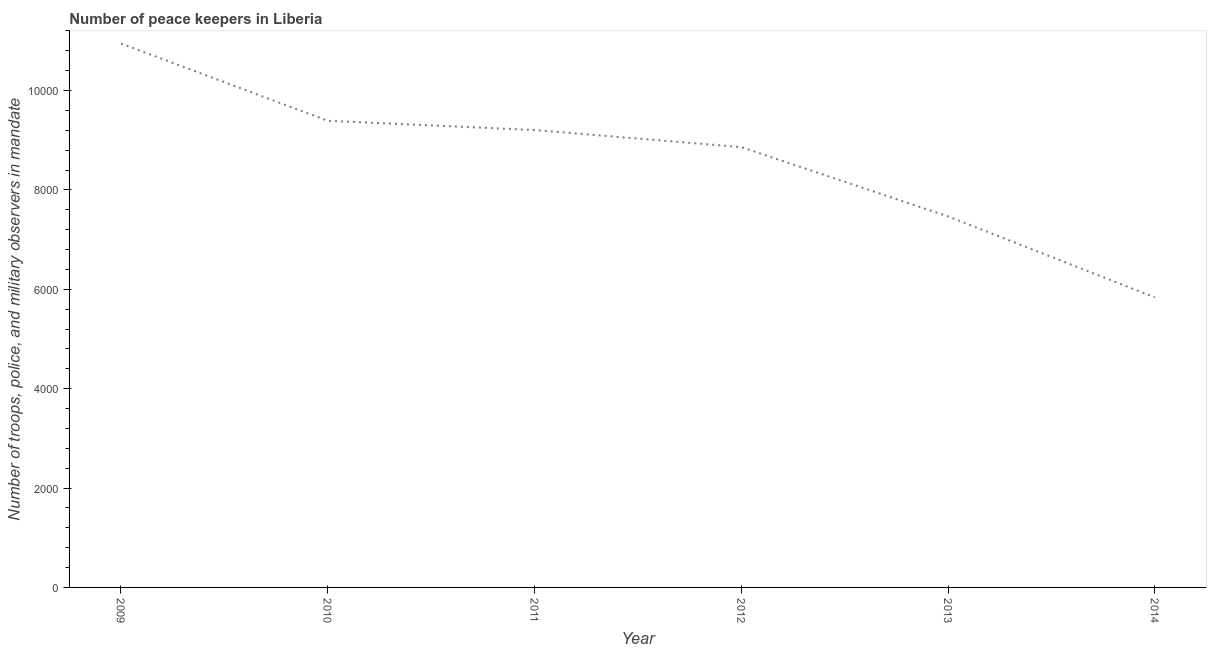What is the number of peace keepers in 2013?
Provide a short and direct response. 7467. Across all years, what is the maximum number of peace keepers?
Make the answer very short. 1.09e+04. Across all years, what is the minimum number of peace keepers?
Give a very brief answer. 5838. In which year was the number of peace keepers maximum?
Your answer should be very brief. 2009. What is the sum of the number of peace keepers?
Provide a succinct answer. 5.17e+04. What is the difference between the number of peace keepers in 2010 and 2013?
Your answer should be compact. 1925. What is the average number of peace keepers per year?
Provide a short and direct response. 8618.67. What is the median number of peace keepers?
Your answer should be compact. 9034. In how many years, is the number of peace keepers greater than 8800 ?
Make the answer very short. 4. Do a majority of the years between 2009 and 2011 (inclusive) have number of peace keepers greater than 4000 ?
Your response must be concise. Yes. What is the ratio of the number of peace keepers in 2009 to that in 2010?
Give a very brief answer. 1.17. What is the difference between the highest and the second highest number of peace keepers?
Provide a short and direct response. 1555. Is the sum of the number of peace keepers in 2010 and 2013 greater than the maximum number of peace keepers across all years?
Your response must be concise. Yes. What is the difference between the highest and the lowest number of peace keepers?
Provide a short and direct response. 5109. In how many years, is the number of peace keepers greater than the average number of peace keepers taken over all years?
Your answer should be compact. 4. Does the number of peace keepers monotonically increase over the years?
Keep it short and to the point. No. What is the difference between two consecutive major ticks on the Y-axis?
Your answer should be very brief. 2000. Does the graph contain any zero values?
Offer a terse response. No. What is the title of the graph?
Give a very brief answer. Number of peace keepers in Liberia. What is the label or title of the X-axis?
Keep it short and to the point. Year. What is the label or title of the Y-axis?
Provide a succinct answer. Number of troops, police, and military observers in mandate. What is the Number of troops, police, and military observers in mandate in 2009?
Make the answer very short. 1.09e+04. What is the Number of troops, police, and military observers in mandate of 2010?
Your answer should be very brief. 9392. What is the Number of troops, police, and military observers in mandate in 2011?
Give a very brief answer. 9206. What is the Number of troops, police, and military observers in mandate of 2012?
Your response must be concise. 8862. What is the Number of troops, police, and military observers in mandate in 2013?
Offer a very short reply. 7467. What is the Number of troops, police, and military observers in mandate of 2014?
Offer a very short reply. 5838. What is the difference between the Number of troops, police, and military observers in mandate in 2009 and 2010?
Provide a succinct answer. 1555. What is the difference between the Number of troops, police, and military observers in mandate in 2009 and 2011?
Make the answer very short. 1741. What is the difference between the Number of troops, police, and military observers in mandate in 2009 and 2012?
Offer a very short reply. 2085. What is the difference between the Number of troops, police, and military observers in mandate in 2009 and 2013?
Provide a succinct answer. 3480. What is the difference between the Number of troops, police, and military observers in mandate in 2009 and 2014?
Offer a terse response. 5109. What is the difference between the Number of troops, police, and military observers in mandate in 2010 and 2011?
Offer a very short reply. 186. What is the difference between the Number of troops, police, and military observers in mandate in 2010 and 2012?
Provide a short and direct response. 530. What is the difference between the Number of troops, police, and military observers in mandate in 2010 and 2013?
Your answer should be compact. 1925. What is the difference between the Number of troops, police, and military observers in mandate in 2010 and 2014?
Your response must be concise. 3554. What is the difference between the Number of troops, police, and military observers in mandate in 2011 and 2012?
Provide a short and direct response. 344. What is the difference between the Number of troops, police, and military observers in mandate in 2011 and 2013?
Your answer should be very brief. 1739. What is the difference between the Number of troops, police, and military observers in mandate in 2011 and 2014?
Your answer should be very brief. 3368. What is the difference between the Number of troops, police, and military observers in mandate in 2012 and 2013?
Make the answer very short. 1395. What is the difference between the Number of troops, police, and military observers in mandate in 2012 and 2014?
Your answer should be compact. 3024. What is the difference between the Number of troops, police, and military observers in mandate in 2013 and 2014?
Offer a very short reply. 1629. What is the ratio of the Number of troops, police, and military observers in mandate in 2009 to that in 2010?
Your answer should be compact. 1.17. What is the ratio of the Number of troops, police, and military observers in mandate in 2009 to that in 2011?
Provide a short and direct response. 1.19. What is the ratio of the Number of troops, police, and military observers in mandate in 2009 to that in 2012?
Make the answer very short. 1.24. What is the ratio of the Number of troops, police, and military observers in mandate in 2009 to that in 2013?
Keep it short and to the point. 1.47. What is the ratio of the Number of troops, police, and military observers in mandate in 2009 to that in 2014?
Keep it short and to the point. 1.88. What is the ratio of the Number of troops, police, and military observers in mandate in 2010 to that in 2012?
Keep it short and to the point. 1.06. What is the ratio of the Number of troops, police, and military observers in mandate in 2010 to that in 2013?
Ensure brevity in your answer.  1.26. What is the ratio of the Number of troops, police, and military observers in mandate in 2010 to that in 2014?
Provide a short and direct response. 1.61. What is the ratio of the Number of troops, police, and military observers in mandate in 2011 to that in 2012?
Ensure brevity in your answer.  1.04. What is the ratio of the Number of troops, police, and military observers in mandate in 2011 to that in 2013?
Provide a short and direct response. 1.23. What is the ratio of the Number of troops, police, and military observers in mandate in 2011 to that in 2014?
Keep it short and to the point. 1.58. What is the ratio of the Number of troops, police, and military observers in mandate in 2012 to that in 2013?
Provide a succinct answer. 1.19. What is the ratio of the Number of troops, police, and military observers in mandate in 2012 to that in 2014?
Make the answer very short. 1.52. What is the ratio of the Number of troops, police, and military observers in mandate in 2013 to that in 2014?
Your response must be concise. 1.28. 